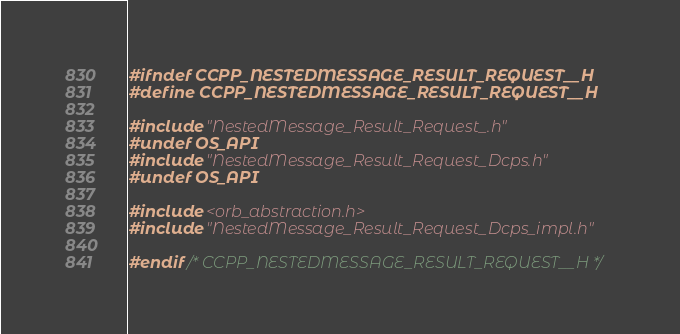Convert code to text. <code><loc_0><loc_0><loc_500><loc_500><_C_>#ifndef CCPP_NESTEDMESSAGE_RESULT_REQUEST__H
#define CCPP_NESTEDMESSAGE_RESULT_REQUEST__H

#include "NestedMessage_Result_Request_.h"
#undef OS_API
#include "NestedMessage_Result_Request_Dcps.h"
#undef OS_API

#include <orb_abstraction.h>
#include "NestedMessage_Result_Request_Dcps_impl.h"

#endif /* CCPP_NESTEDMESSAGE_RESULT_REQUEST__H */
</code> 